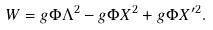Convert formula to latex. <formula><loc_0><loc_0><loc_500><loc_500>W = g \Phi \Lambda ^ { 2 } - g \Phi X ^ { 2 } + g \Phi X ^ { \prime 2 } .</formula> 